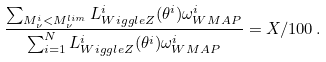Convert formula to latex. <formula><loc_0><loc_0><loc_500><loc_500>\frac { \sum _ { M _ { \nu } ^ { i } < M _ { \nu } ^ { l i m } } L ^ { i } _ { W i g g l e Z } ( \theta ^ { i } ) \omega ^ { i } _ { W M A P } } { \sum _ { i = 1 } ^ { N } L ^ { i } _ { W i g g l e Z } ( \theta ^ { i } ) \omega ^ { i } _ { W M A P } } = X / 1 0 0 \, .</formula> 